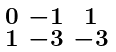Convert formula to latex. <formula><loc_0><loc_0><loc_500><loc_500>\begin{smallmatrix} 0 & - 1 & 1 \\ 1 & - 3 & - 3 \end{smallmatrix}</formula> 